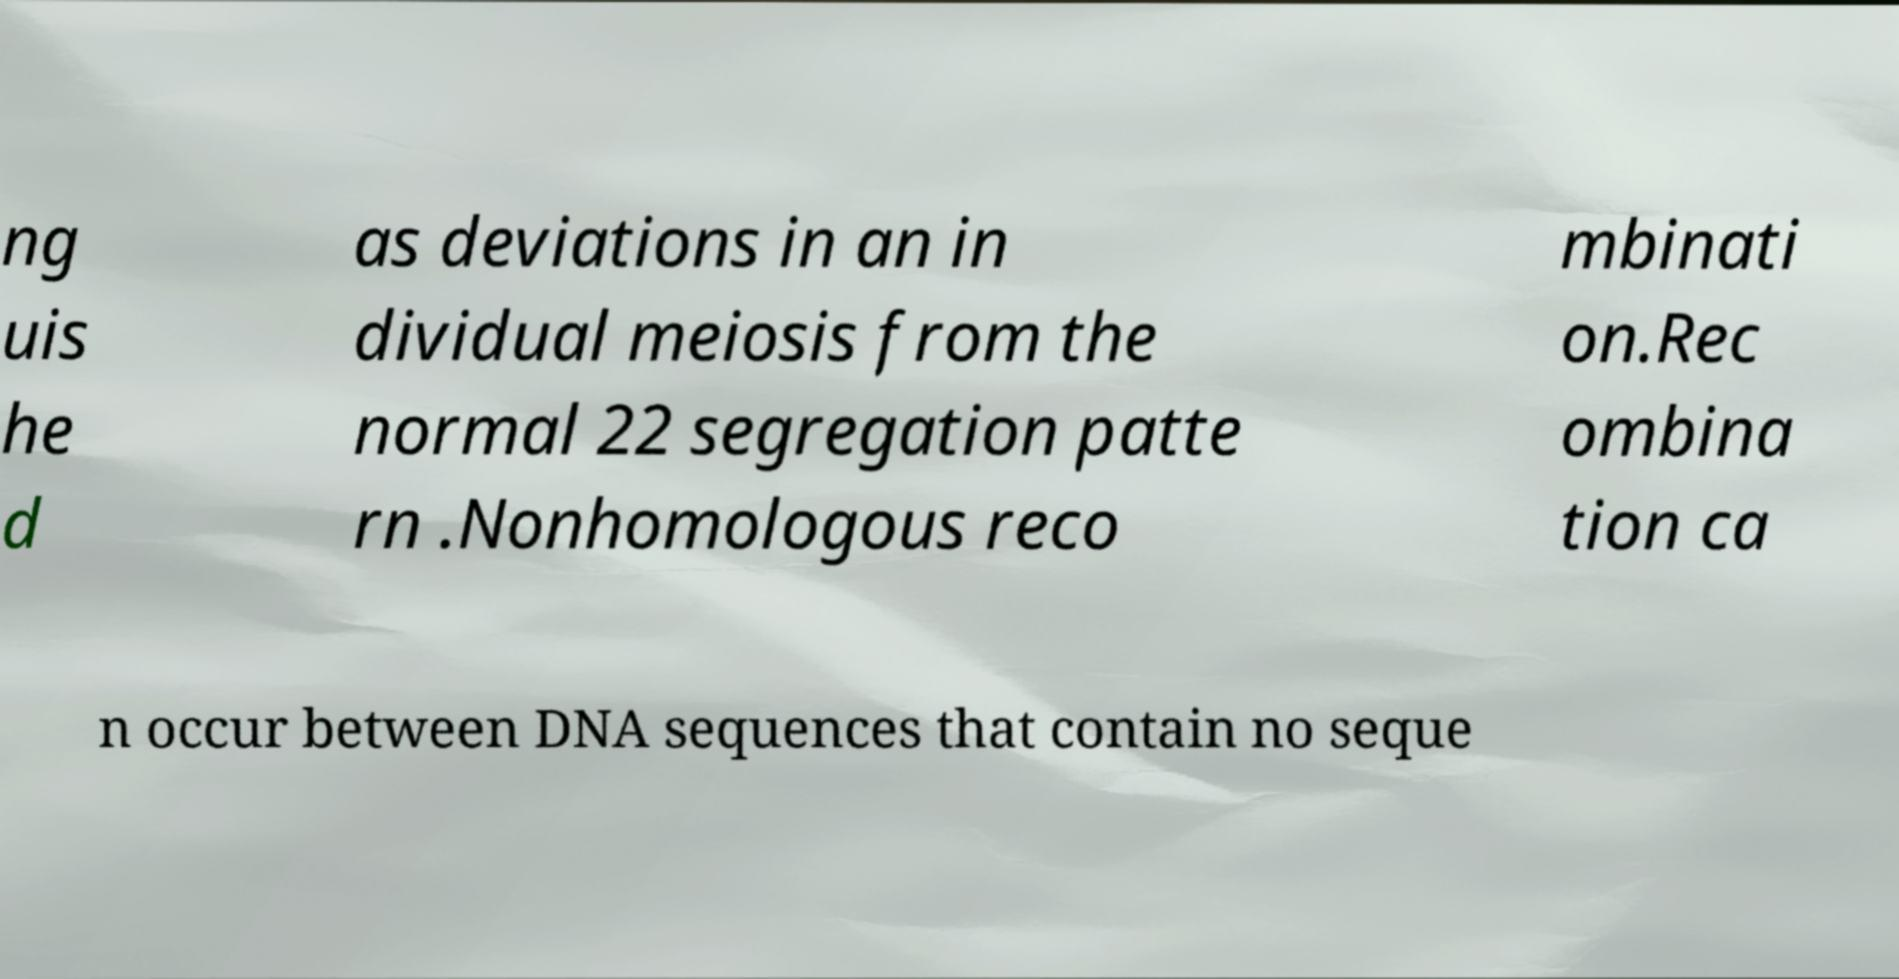I need the written content from this picture converted into text. Can you do that? ng uis he d as deviations in an in dividual meiosis from the normal 22 segregation patte rn .Nonhomologous reco mbinati on.Rec ombina tion ca n occur between DNA sequences that contain no seque 